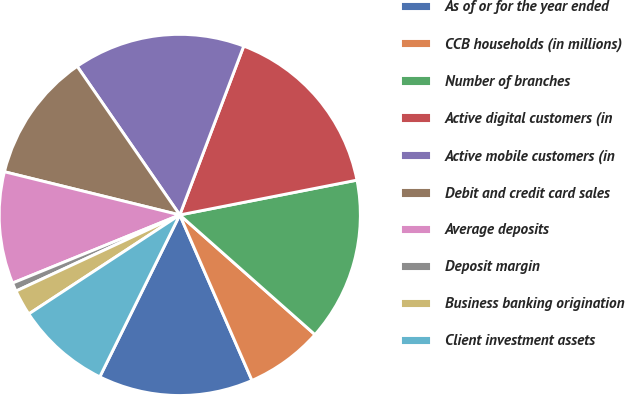Convert chart to OTSL. <chart><loc_0><loc_0><loc_500><loc_500><pie_chart><fcel>As of or for the year ended<fcel>CCB households (in millions)<fcel>Number of branches<fcel>Active digital customers (in<fcel>Active mobile customers (in<fcel>Debit and credit card sales<fcel>Average deposits<fcel>Deposit margin<fcel>Business banking origination<fcel>Client investment assets<nl><fcel>13.85%<fcel>6.92%<fcel>14.62%<fcel>16.15%<fcel>15.38%<fcel>11.54%<fcel>10.0%<fcel>0.77%<fcel>2.31%<fcel>8.46%<nl></chart> 